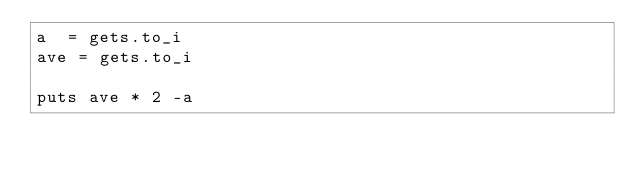<code> <loc_0><loc_0><loc_500><loc_500><_Ruby_>a  = gets.to_i
ave = gets.to_i

puts ave * 2 -a</code> 